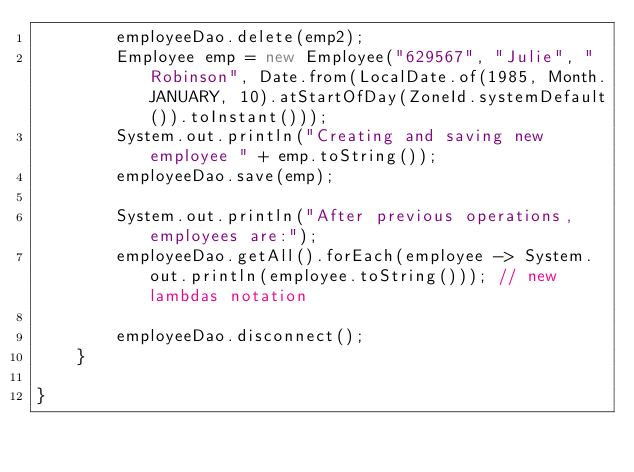Convert code to text. <code><loc_0><loc_0><loc_500><loc_500><_Java_>        employeeDao.delete(emp2);
        Employee emp = new Employee("629567", "Julie", "Robinson", Date.from(LocalDate.of(1985, Month.JANUARY, 10).atStartOfDay(ZoneId.systemDefault()).toInstant()));
        System.out.println("Creating and saving new employee " + emp.toString());
        employeeDao.save(emp);

        System.out.println("After previous operations, employees are:");
        employeeDao.getAll().forEach(employee -> System.out.println(employee.toString())); // new lambdas notation
    
        employeeDao.disconnect();
    }
    
}
</code> 